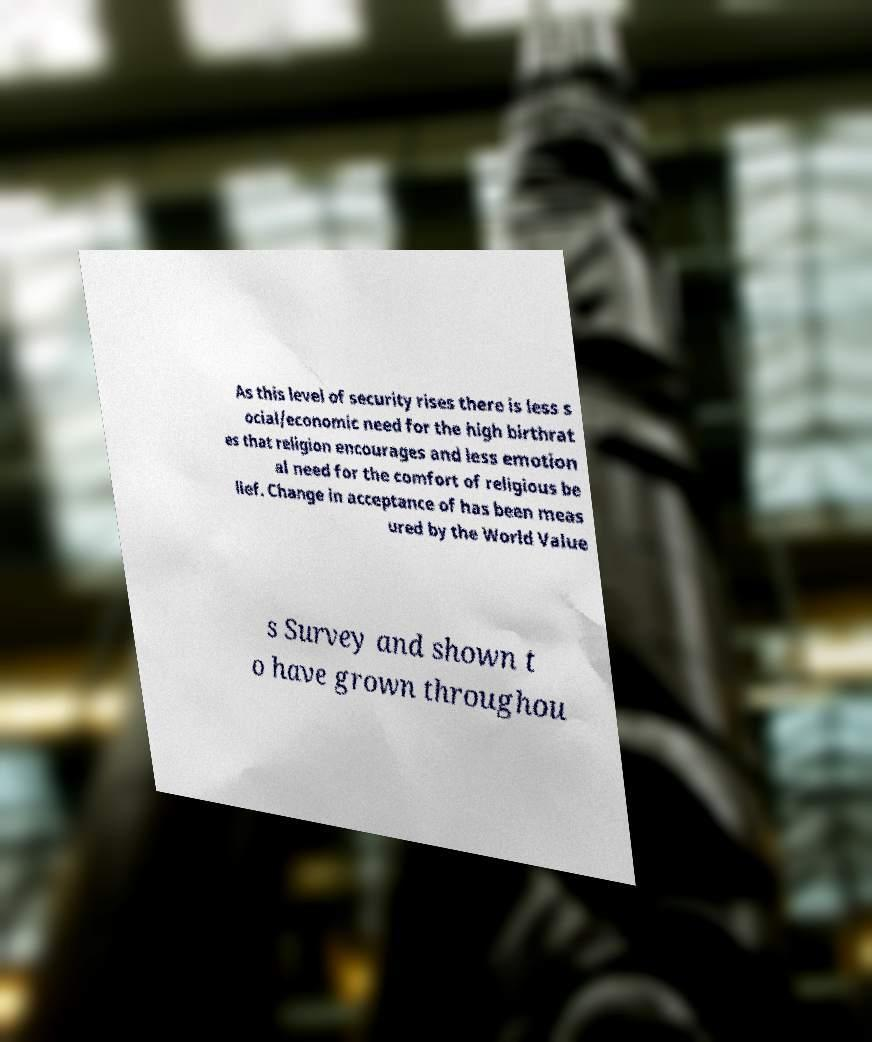There's text embedded in this image that I need extracted. Can you transcribe it verbatim? As this level of security rises there is less s ocial/economic need for the high birthrat es that religion encourages and less emotion al need for the comfort of religious be lief. Change in acceptance of has been meas ured by the World Value s Survey and shown t o have grown throughou 